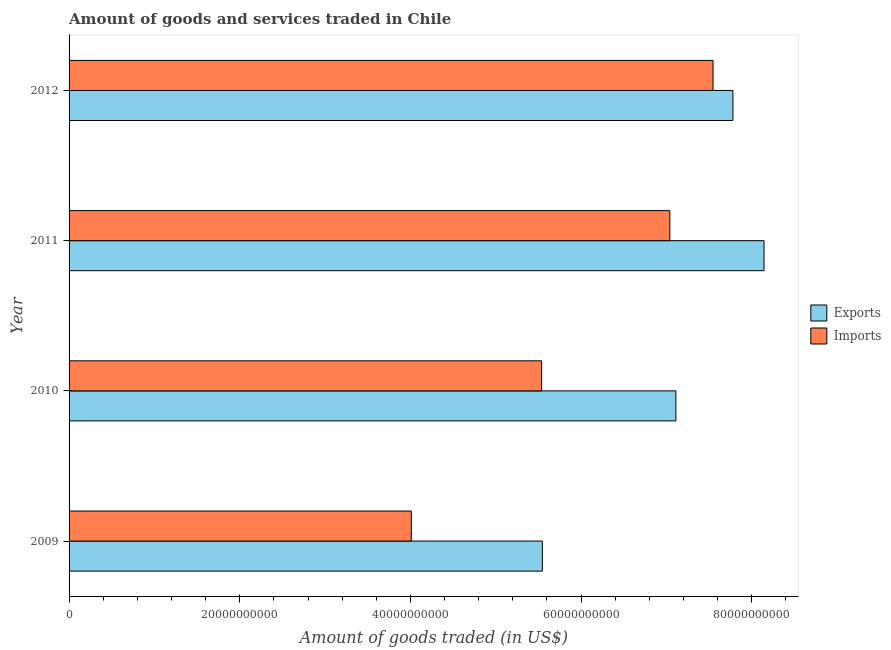Are the number of bars per tick equal to the number of legend labels?
Provide a short and direct response. Yes. How many bars are there on the 3rd tick from the top?
Your response must be concise. 2. How many bars are there on the 3rd tick from the bottom?
Provide a succinct answer. 2. In how many cases, is the number of bars for a given year not equal to the number of legend labels?
Provide a succinct answer. 0. What is the amount of goods exported in 2011?
Provide a succinct answer. 8.14e+1. Across all years, what is the maximum amount of goods exported?
Make the answer very short. 8.14e+1. Across all years, what is the minimum amount of goods exported?
Provide a short and direct response. 5.55e+1. What is the total amount of goods exported in the graph?
Your answer should be compact. 2.86e+11. What is the difference between the amount of goods imported in 2009 and that in 2010?
Your answer should be very brief. -1.53e+1. What is the difference between the amount of goods exported in 2009 and the amount of goods imported in 2012?
Your answer should be compact. -2.00e+1. What is the average amount of goods exported per year?
Your answer should be very brief. 7.14e+1. In the year 2010, what is the difference between the amount of goods exported and amount of goods imported?
Keep it short and to the point. 1.57e+1. In how many years, is the amount of goods imported greater than 8000000000 US$?
Give a very brief answer. 4. What is the ratio of the amount of goods imported in 2011 to that in 2012?
Offer a terse response. 0.93. Is the difference between the amount of goods exported in 2009 and 2010 greater than the difference between the amount of goods imported in 2009 and 2010?
Ensure brevity in your answer.  No. What is the difference between the highest and the second highest amount of goods imported?
Your response must be concise. 5.06e+09. What is the difference between the highest and the lowest amount of goods exported?
Offer a very short reply. 2.60e+1. In how many years, is the amount of goods exported greater than the average amount of goods exported taken over all years?
Provide a succinct answer. 2. Is the sum of the amount of goods exported in 2009 and 2012 greater than the maximum amount of goods imported across all years?
Offer a very short reply. Yes. What does the 1st bar from the top in 2009 represents?
Provide a succinct answer. Imports. What does the 2nd bar from the bottom in 2012 represents?
Offer a terse response. Imports. How many bars are there?
Give a very brief answer. 8. Are all the bars in the graph horizontal?
Provide a succinct answer. Yes. How many years are there in the graph?
Ensure brevity in your answer.  4. What is the difference between two consecutive major ticks on the X-axis?
Offer a very short reply. 2.00e+1. Does the graph contain grids?
Offer a terse response. No. How are the legend labels stacked?
Provide a short and direct response. Vertical. What is the title of the graph?
Provide a short and direct response. Amount of goods and services traded in Chile. Does "From World Bank" appear as one of the legend labels in the graph?
Keep it short and to the point. No. What is the label or title of the X-axis?
Provide a short and direct response. Amount of goods traded (in US$). What is the Amount of goods traded (in US$) of Exports in 2009?
Offer a terse response. 5.55e+1. What is the Amount of goods traded (in US$) in Imports in 2009?
Your answer should be compact. 4.01e+1. What is the Amount of goods traded (in US$) in Exports in 2010?
Provide a succinct answer. 7.11e+1. What is the Amount of goods traded (in US$) in Imports in 2010?
Provide a succinct answer. 5.54e+1. What is the Amount of goods traded (in US$) in Exports in 2011?
Keep it short and to the point. 8.14e+1. What is the Amount of goods traded (in US$) in Imports in 2011?
Your response must be concise. 7.04e+1. What is the Amount of goods traded (in US$) in Exports in 2012?
Keep it short and to the point. 7.78e+1. What is the Amount of goods traded (in US$) of Imports in 2012?
Keep it short and to the point. 7.55e+1. Across all years, what is the maximum Amount of goods traded (in US$) in Exports?
Offer a very short reply. 8.14e+1. Across all years, what is the maximum Amount of goods traded (in US$) of Imports?
Your response must be concise. 7.55e+1. Across all years, what is the minimum Amount of goods traded (in US$) of Exports?
Give a very brief answer. 5.55e+1. Across all years, what is the minimum Amount of goods traded (in US$) in Imports?
Provide a succinct answer. 4.01e+1. What is the total Amount of goods traded (in US$) in Exports in the graph?
Your answer should be very brief. 2.86e+11. What is the total Amount of goods traded (in US$) of Imports in the graph?
Keep it short and to the point. 2.41e+11. What is the difference between the Amount of goods traded (in US$) in Exports in 2009 and that in 2010?
Your response must be concise. -1.56e+1. What is the difference between the Amount of goods traded (in US$) in Imports in 2009 and that in 2010?
Ensure brevity in your answer.  -1.53e+1. What is the difference between the Amount of goods traded (in US$) in Exports in 2009 and that in 2011?
Give a very brief answer. -2.60e+1. What is the difference between the Amount of goods traded (in US$) of Imports in 2009 and that in 2011?
Make the answer very short. -3.03e+1. What is the difference between the Amount of goods traded (in US$) of Exports in 2009 and that in 2012?
Give a very brief answer. -2.23e+1. What is the difference between the Amount of goods traded (in US$) of Imports in 2009 and that in 2012?
Ensure brevity in your answer.  -3.54e+1. What is the difference between the Amount of goods traded (in US$) of Exports in 2010 and that in 2011?
Provide a succinct answer. -1.03e+1. What is the difference between the Amount of goods traded (in US$) in Imports in 2010 and that in 2011?
Make the answer very short. -1.50e+1. What is the difference between the Amount of goods traded (in US$) in Exports in 2010 and that in 2012?
Your answer should be compact. -6.68e+09. What is the difference between the Amount of goods traded (in US$) of Imports in 2010 and that in 2012?
Offer a very short reply. -2.01e+1. What is the difference between the Amount of goods traded (in US$) of Exports in 2011 and that in 2012?
Provide a succinct answer. 3.65e+09. What is the difference between the Amount of goods traded (in US$) of Imports in 2011 and that in 2012?
Your answer should be compact. -5.06e+09. What is the difference between the Amount of goods traded (in US$) in Exports in 2009 and the Amount of goods traded (in US$) in Imports in 2010?
Give a very brief answer. 9.06e+07. What is the difference between the Amount of goods traded (in US$) in Exports in 2009 and the Amount of goods traded (in US$) in Imports in 2011?
Offer a terse response. -1.49e+1. What is the difference between the Amount of goods traded (in US$) in Exports in 2009 and the Amount of goods traded (in US$) in Imports in 2012?
Give a very brief answer. -2.00e+1. What is the difference between the Amount of goods traded (in US$) in Exports in 2010 and the Amount of goods traded (in US$) in Imports in 2011?
Make the answer very short. 7.10e+08. What is the difference between the Amount of goods traded (in US$) in Exports in 2010 and the Amount of goods traded (in US$) in Imports in 2012?
Offer a terse response. -4.35e+09. What is the difference between the Amount of goods traded (in US$) in Exports in 2011 and the Amount of goods traded (in US$) in Imports in 2012?
Provide a succinct answer. 5.98e+09. What is the average Amount of goods traded (in US$) in Exports per year?
Give a very brief answer. 7.14e+1. What is the average Amount of goods traded (in US$) of Imports per year?
Give a very brief answer. 6.03e+1. In the year 2009, what is the difference between the Amount of goods traded (in US$) in Exports and Amount of goods traded (in US$) in Imports?
Your answer should be compact. 1.54e+1. In the year 2010, what is the difference between the Amount of goods traded (in US$) in Exports and Amount of goods traded (in US$) in Imports?
Provide a succinct answer. 1.57e+1. In the year 2011, what is the difference between the Amount of goods traded (in US$) in Exports and Amount of goods traded (in US$) in Imports?
Provide a short and direct response. 1.10e+1. In the year 2012, what is the difference between the Amount of goods traded (in US$) in Exports and Amount of goods traded (in US$) in Imports?
Your answer should be very brief. 2.33e+09. What is the ratio of the Amount of goods traded (in US$) of Exports in 2009 to that in 2010?
Keep it short and to the point. 0.78. What is the ratio of the Amount of goods traded (in US$) of Imports in 2009 to that in 2010?
Ensure brevity in your answer.  0.72. What is the ratio of the Amount of goods traded (in US$) of Exports in 2009 to that in 2011?
Provide a short and direct response. 0.68. What is the ratio of the Amount of goods traded (in US$) of Imports in 2009 to that in 2011?
Make the answer very short. 0.57. What is the ratio of the Amount of goods traded (in US$) of Exports in 2009 to that in 2012?
Keep it short and to the point. 0.71. What is the ratio of the Amount of goods traded (in US$) in Imports in 2009 to that in 2012?
Keep it short and to the point. 0.53. What is the ratio of the Amount of goods traded (in US$) in Exports in 2010 to that in 2011?
Give a very brief answer. 0.87. What is the ratio of the Amount of goods traded (in US$) of Imports in 2010 to that in 2011?
Ensure brevity in your answer.  0.79. What is the ratio of the Amount of goods traded (in US$) of Exports in 2010 to that in 2012?
Ensure brevity in your answer.  0.91. What is the ratio of the Amount of goods traded (in US$) of Imports in 2010 to that in 2012?
Your answer should be very brief. 0.73. What is the ratio of the Amount of goods traded (in US$) in Exports in 2011 to that in 2012?
Your answer should be compact. 1.05. What is the ratio of the Amount of goods traded (in US$) of Imports in 2011 to that in 2012?
Offer a very short reply. 0.93. What is the difference between the highest and the second highest Amount of goods traded (in US$) of Exports?
Your answer should be very brief. 3.65e+09. What is the difference between the highest and the second highest Amount of goods traded (in US$) in Imports?
Offer a very short reply. 5.06e+09. What is the difference between the highest and the lowest Amount of goods traded (in US$) in Exports?
Keep it short and to the point. 2.60e+1. What is the difference between the highest and the lowest Amount of goods traded (in US$) of Imports?
Provide a short and direct response. 3.54e+1. 